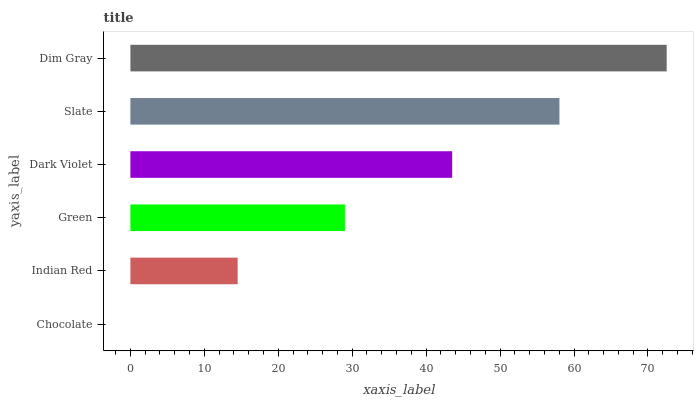Is Chocolate the minimum?
Answer yes or no. Yes. Is Dim Gray the maximum?
Answer yes or no. Yes. Is Indian Red the minimum?
Answer yes or no. No. Is Indian Red the maximum?
Answer yes or no. No. Is Indian Red greater than Chocolate?
Answer yes or no. Yes. Is Chocolate less than Indian Red?
Answer yes or no. Yes. Is Chocolate greater than Indian Red?
Answer yes or no. No. Is Indian Red less than Chocolate?
Answer yes or no. No. Is Dark Violet the high median?
Answer yes or no. Yes. Is Green the low median?
Answer yes or no. Yes. Is Indian Red the high median?
Answer yes or no. No. Is Chocolate the low median?
Answer yes or no. No. 